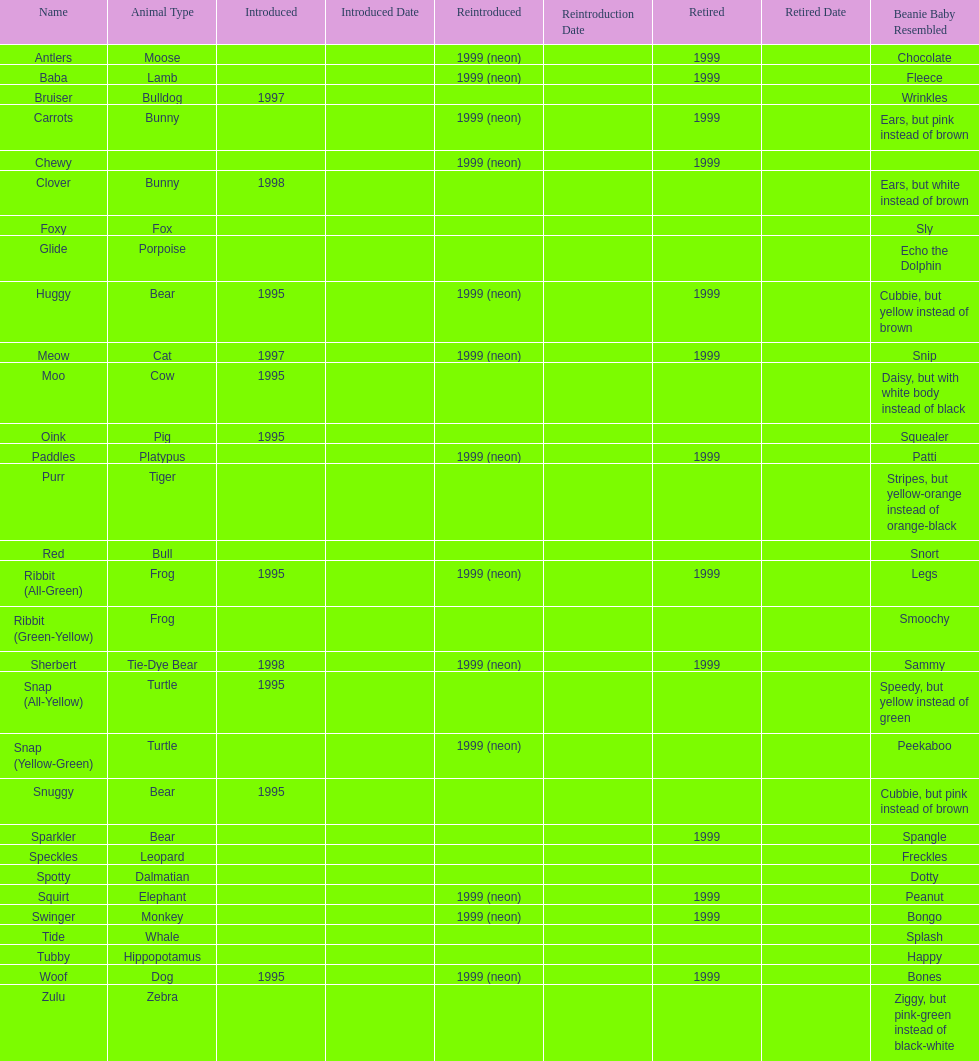How long was woof the dog sold before it was retired? 4 years. 